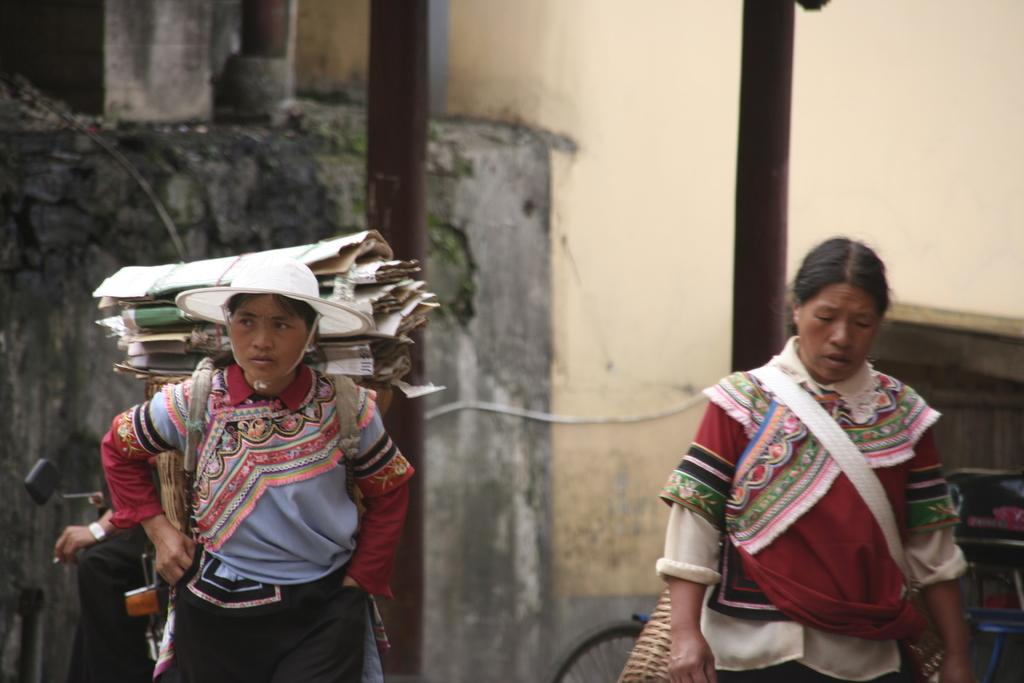How many women are present in the image? There are two women in the image. What are the women doing in the image? The women are carrying loads on their backs. What are the women wearing in the image? The women are wearing colorful costumes. What can be seen in the background of the image? There are electric poles and at least one building visible in the image. Can you tell me how many hands are visible in the image? There is no specific mention of hands in the image, so it is not possible to determine how many hands are visible. --- Facts: 1. There is a car in the image. 2. The car is parked on the side of the road. 3. There are trees in the background of the image. 4. The sky is visible in the image. 5. The car has a flat tire. Absurd Topics: parrot, ocean, dance Conversation: What is the main subject of the image? The main subject of the image is a car. Where is the car located in the image? The car is parked on the side of the road. What can be seen in the background of the image? There are trees and the sky visible in the image. What is the condition of the car in the image? The car has a flat tire. Reasoning: Let's think step by step in order to produce the conversation. We start by identifying the main subject of the image, which is the car. Then, we describe the car's location, noting that it is parked on the side of the road. Next, we mention the background of the image, which includes trees and the sky. Finally, we describe the condition of the car, noting that it has a flat tire. Absurd Question/Answer: Can you tell me how many parrots are sitting on the car in the image? There is no mention of parrots in the image, so it is not possible to determine how many parrots are sitting on the car. 